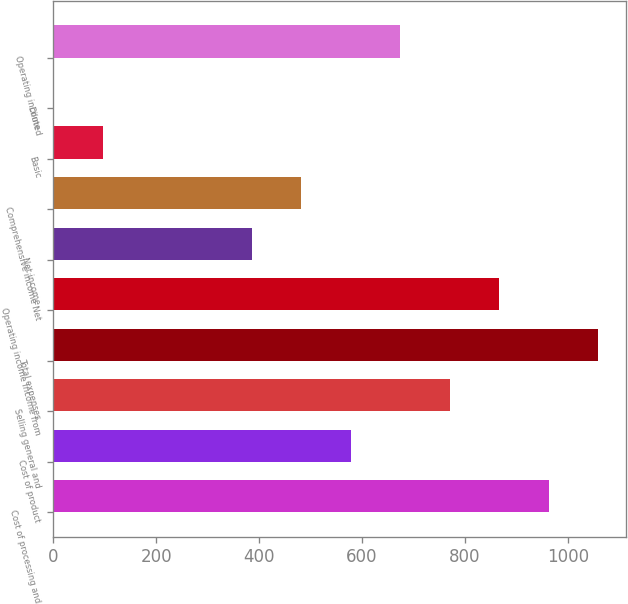<chart> <loc_0><loc_0><loc_500><loc_500><bar_chart><fcel>Cost of processing and<fcel>Cost of product<fcel>Selling general and<fcel>Total expenses<fcel>Operating income Income from<fcel>Net income<fcel>Comprehensive income Net<fcel>Basic<fcel>Diluted<fcel>Operating income<nl><fcel>963.02<fcel>578.08<fcel>770.56<fcel>1059.26<fcel>866.79<fcel>385.6<fcel>481.84<fcel>96.89<fcel>0.65<fcel>674.32<nl></chart> 